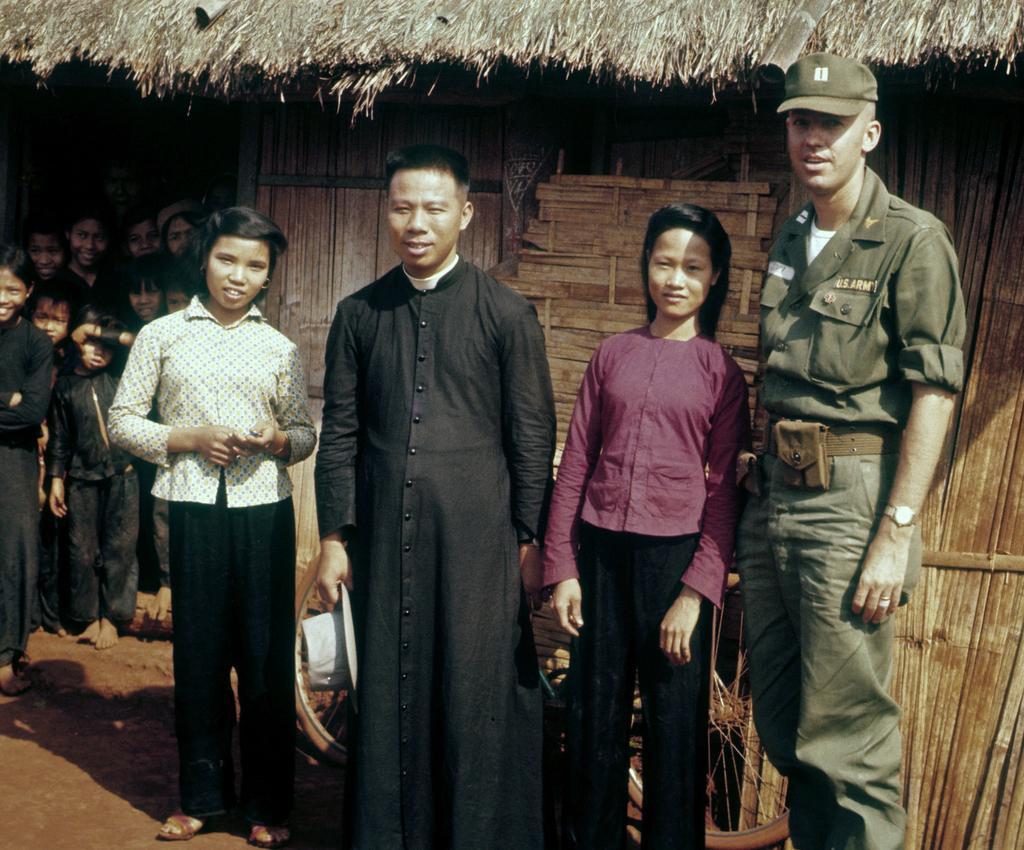How would you summarize this image in a sentence or two? There are four people standing. Person on the right is wearing a watch and cap. another person is holding a hat. In the back there are many people. Also there is a hit with wooden walls. 